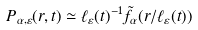Convert formula to latex. <formula><loc_0><loc_0><loc_500><loc_500>P _ { \alpha , \varepsilon } ( r , t ) \simeq \ell _ { \varepsilon } ( t ) ^ { - 1 } \tilde { f } _ { \alpha } ( r / \ell _ { \varepsilon } ( t ) )</formula> 